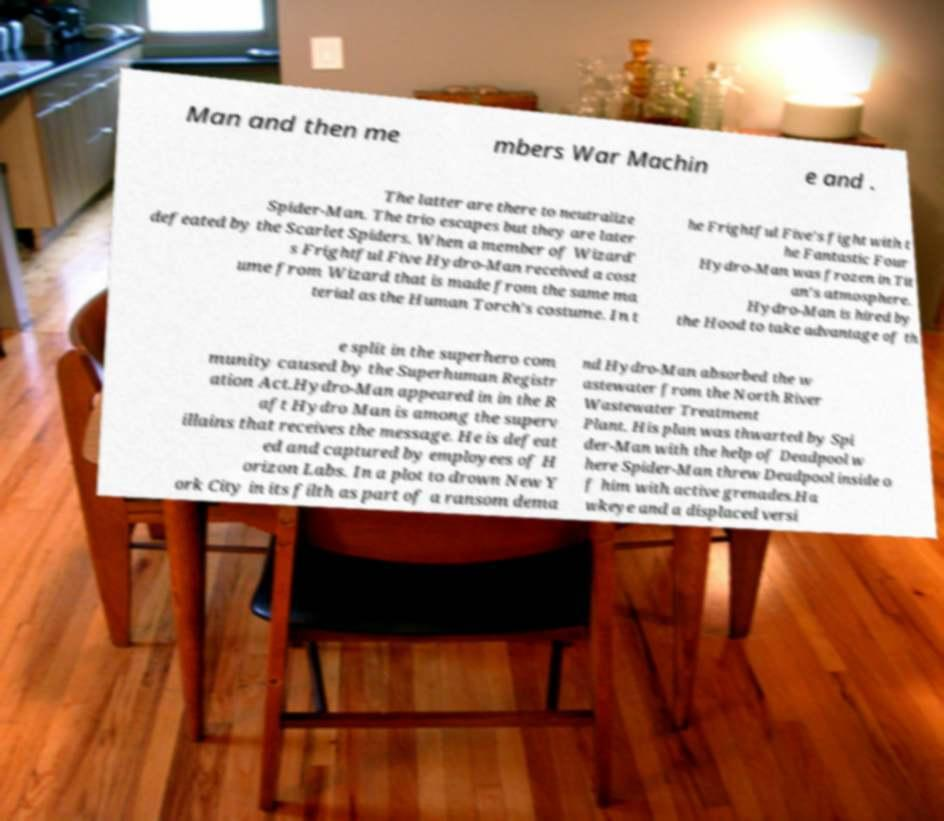There's text embedded in this image that I need extracted. Can you transcribe it verbatim? Man and then me mbers War Machin e and . The latter are there to neutralize Spider-Man. The trio escapes but they are later defeated by the Scarlet Spiders. When a member of Wizard' s Frightful Five Hydro-Man received a cost ume from Wizard that is made from the same ma terial as the Human Torch's costume. In t he Frightful Five's fight with t he Fantastic Four Hydro-Man was frozen in Tit an's atmosphere. Hydro-Man is hired by the Hood to take advantage of th e split in the superhero com munity caused by the Superhuman Registr ation Act.Hydro-Man appeared in in the R aft Hydro Man is among the superv illains that receives the message. He is defeat ed and captured by employees of H orizon Labs. In a plot to drown New Y ork City in its filth as part of a ransom dema nd Hydro-Man absorbed the w astewater from the North River Wastewater Treatment Plant. His plan was thwarted by Spi der-Man with the help of Deadpool w here Spider-Man threw Deadpool inside o f him with active grenades.Ha wkeye and a displaced versi 